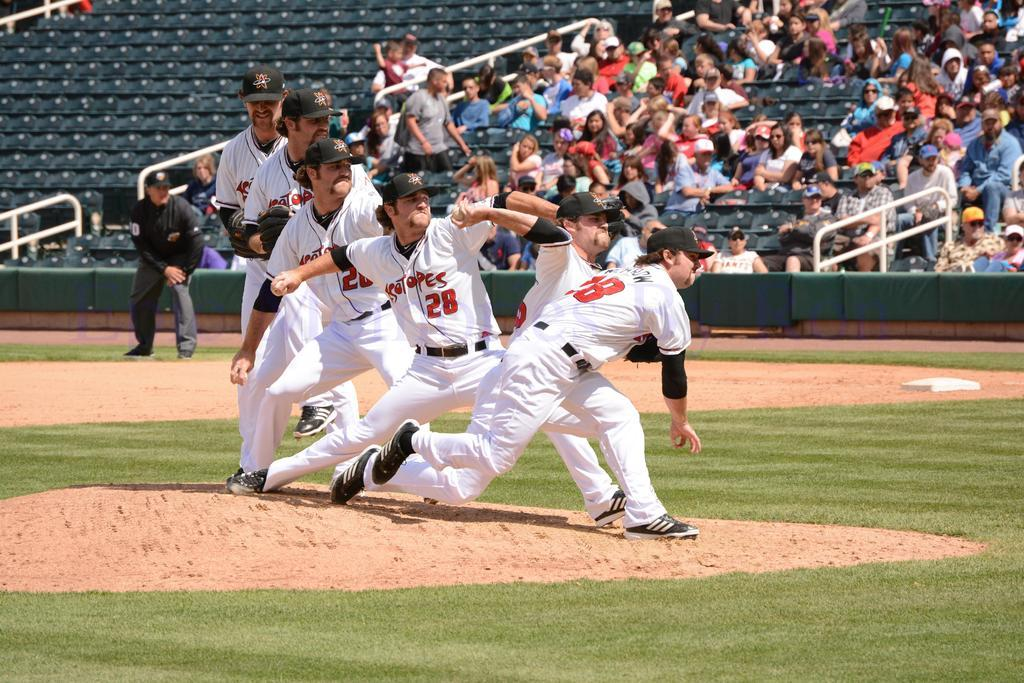<image>
Describe the image concisely. Several players are on a baseball field are wearing Isotopes jerseys. 